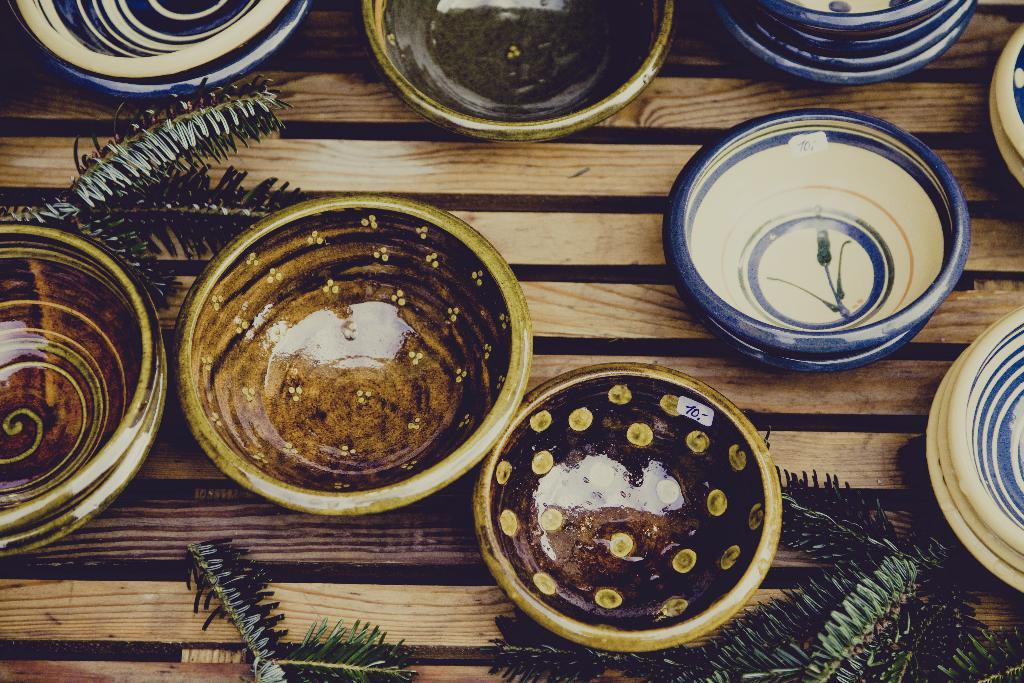What is the primary object visible on the wooden surface in the image? There are many bowls on a wooden surface. Are there any other items visible on the wooden surface besides the bowls? Yes, there are a few leaves on the wooden surface. What type of paste is being used to create the idea in the image? There is no paste or idea present in the image; it only features bowls and leaves on a wooden surface. 